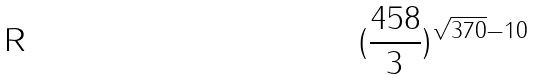Convert formula to latex. <formula><loc_0><loc_0><loc_500><loc_500>( \frac { 4 5 8 } { 3 } ) ^ { \sqrt { 3 7 0 } - 1 0 }</formula> 